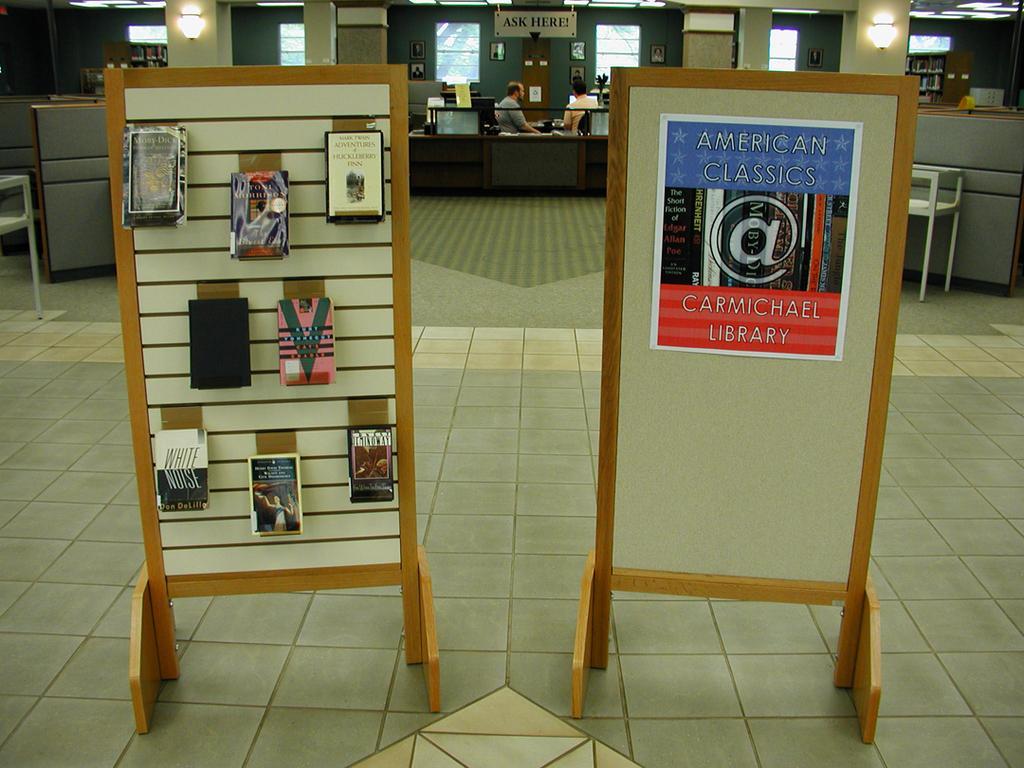Could you give a brief overview of what you see in this image? In this picture we can see persons,pillars,lights,windows and some objects. 